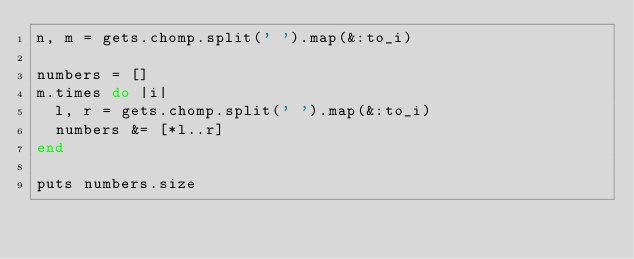<code> <loc_0><loc_0><loc_500><loc_500><_Ruby_>n, m = gets.chomp.split(' ').map(&:to_i)

numbers = []
m.times do |i|
  l, r = gets.chomp.split(' ').map(&:to_i)
  numbers &= [*l..r]
end

puts numbers.size

</code> 